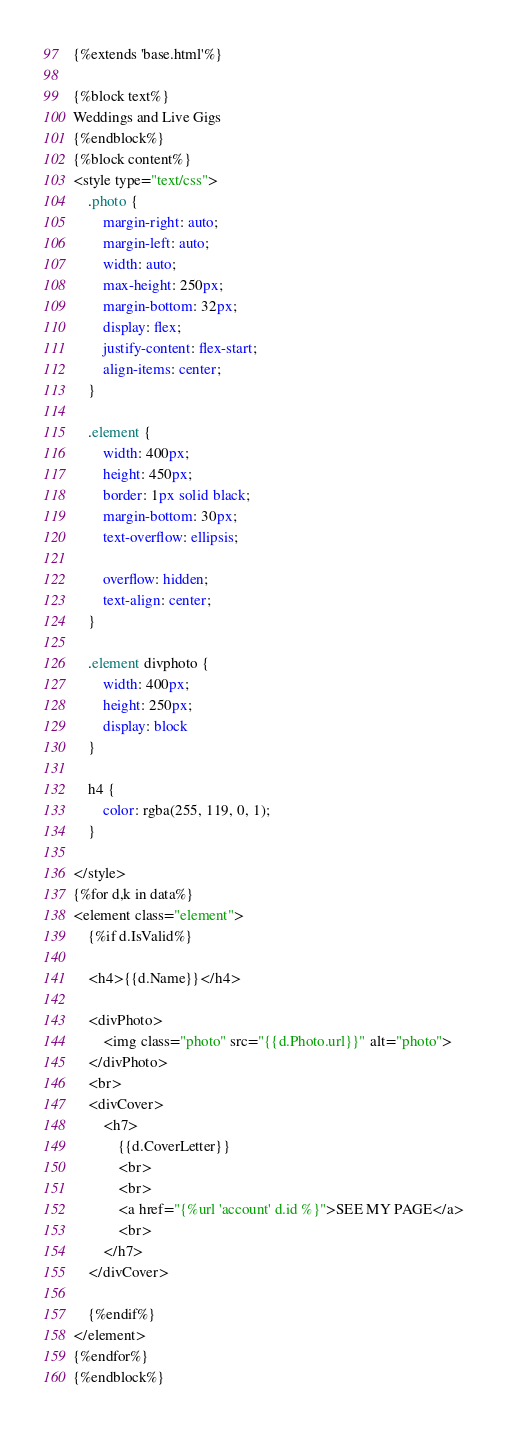Convert code to text. <code><loc_0><loc_0><loc_500><loc_500><_HTML_>{%extends 'base.html'%}

{%block text%}
Weddings and Live Gigs
{%endblock%}
{%block content%}
<style type="text/css">
    .photo {
        margin-right: auto;
        margin-left: auto;
        width: auto;
        max-height: 250px;
        margin-bottom: 32px;
        display: flex;
        justify-content: flex-start;
        align-items: center;
    }

    .element {
        width: 400px;
        height: 450px;
        border: 1px solid black;
        margin-bottom: 30px;
        text-overflow: ellipsis;

        overflow: hidden;
        text-align: center;
    }

    .element divphoto {
        width: 400px;
        height: 250px;
        display: block
    }

    h4 {
        color: rgba(255, 119, 0, 1);
    }

</style>
{%for d,k in data%}
<element class="element">
    {%if d.IsValid%}

    <h4>{{d.Name}}</h4>

    <divPhoto>
        <img class="photo" src="{{d.Photo.url}}" alt="photo">
    </divPhoto>
    <br>
    <divCover>
        <h7>
            {{d.CoverLetter}}
            <br>
            <br>
            <a href="{%url 'account' d.id %}">SEE MY PAGE</a>
            <br>
        </h7>
    </divCover>

    {%endif%}
</element>
{%endfor%}
{%endblock%}
</code> 